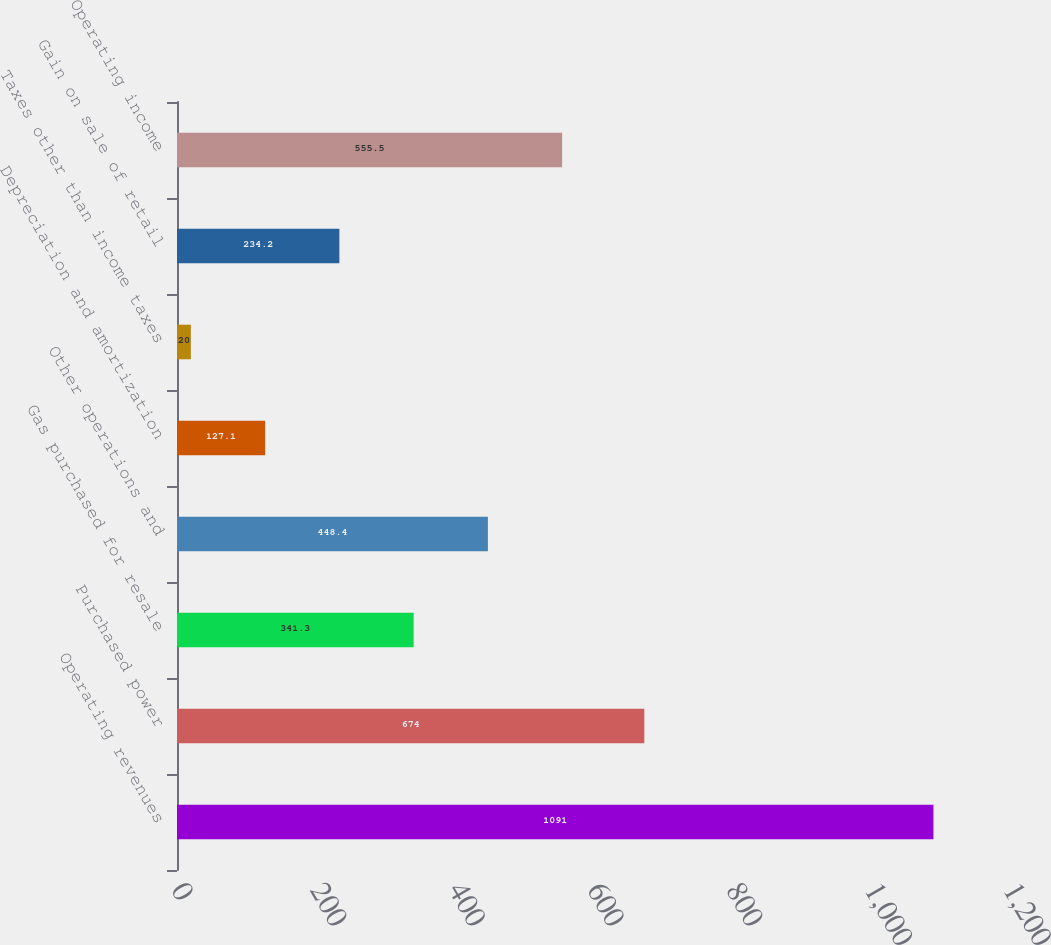<chart> <loc_0><loc_0><loc_500><loc_500><bar_chart><fcel>Operating revenues<fcel>Purchased power<fcel>Gas purchased for resale<fcel>Other operations and<fcel>Depreciation and amortization<fcel>Taxes other than income taxes<fcel>Gain on sale of retail<fcel>Operating income<nl><fcel>1091<fcel>674<fcel>341.3<fcel>448.4<fcel>127.1<fcel>20<fcel>234.2<fcel>555.5<nl></chart> 